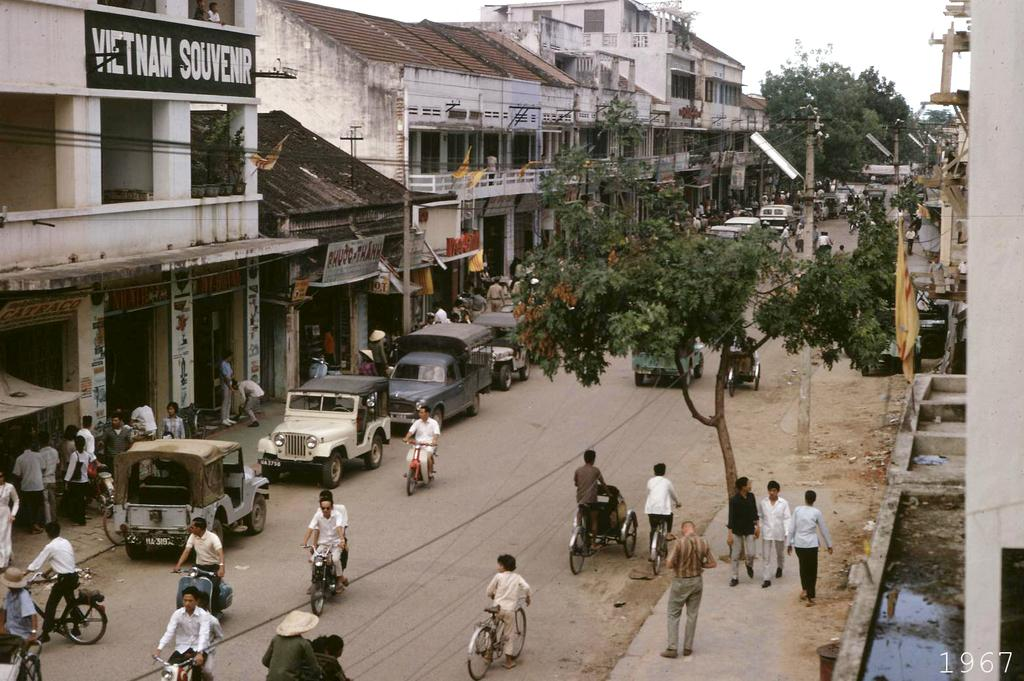<image>
Create a compact narrative representing the image presented. A village of people that are walking an riding scooters down a street of buildings on both sides and one building called Vietnam Souvenir. 